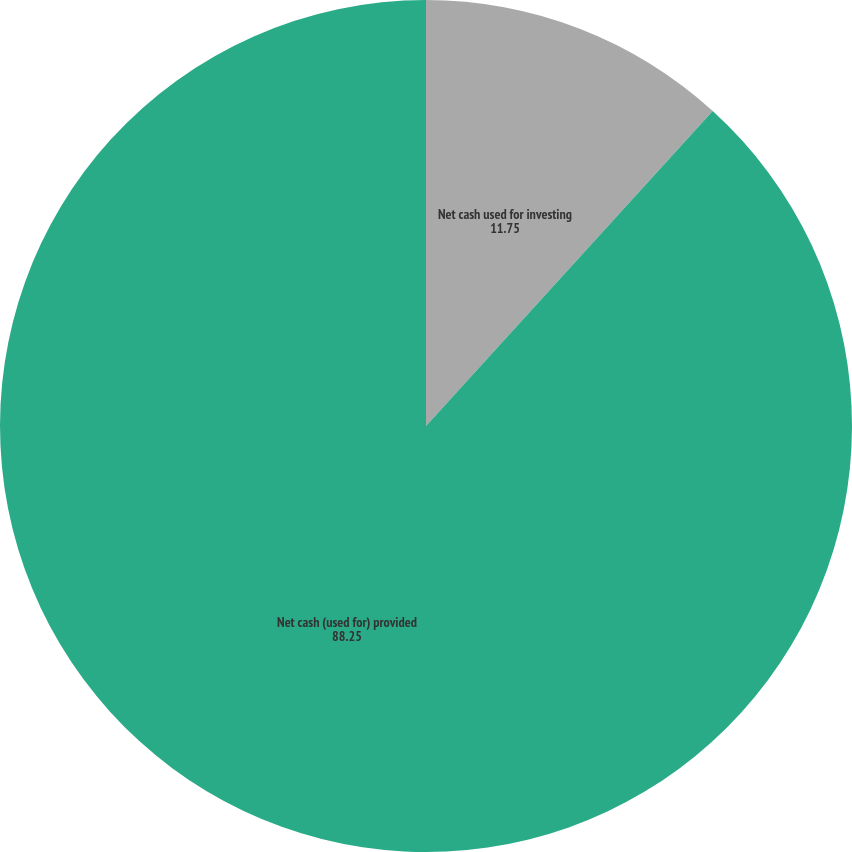Convert chart to OTSL. <chart><loc_0><loc_0><loc_500><loc_500><pie_chart><fcel>Net cash provided by operating<fcel>Net cash used for investing<fcel>Net cash (used for) provided<nl><fcel>0.0%<fcel>11.75%<fcel>88.25%<nl></chart> 